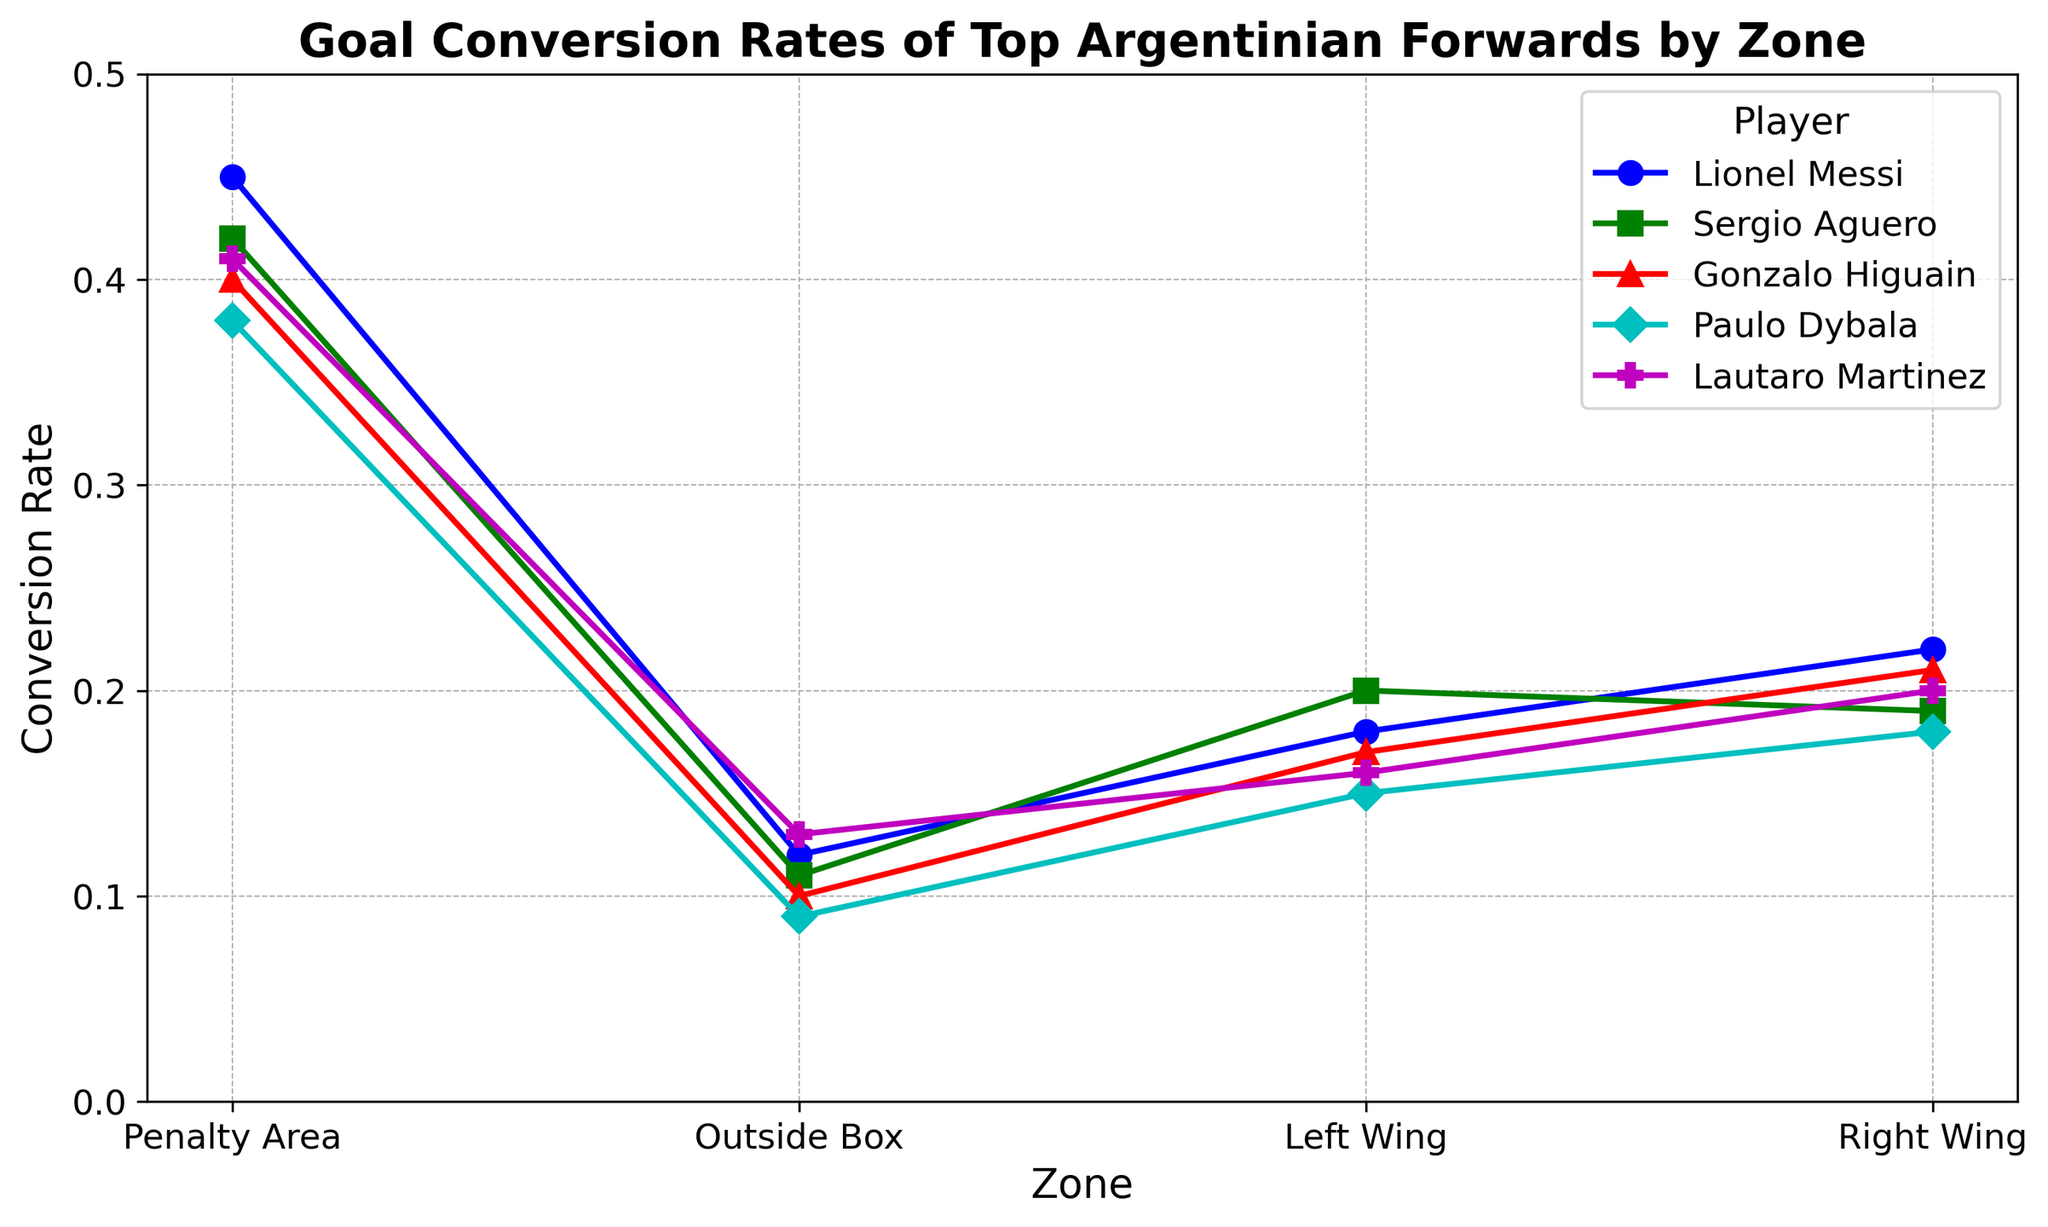Which player has the highest conversion rate in the Penalty Area? To find the player with the highest conversion rate in the Penalty Area, compare the conversion rates for each player in that zone. Lionel Messi has the highest rate at 0.45.
Answer: Lionel Messi Which zone does Paulo Dybala have the lowest conversion rate? Look at Paulo Dybala's conversion rates and find the lowest one. The lowest rate for Paulo Dybala is 0.09 in the Outside Box zone.
Answer: Outside Box Compare the conversion rates of Messi and Aguero in the Right Wing. Who has a higher rate? Compare the conversion rates of both Messi and Aguero in the Right Wing. Messi has a conversion rate of 0.22, while Aguero has 0.19. Therefore, Messi has a higher rate.
Answer: Messi Which zone shows the largest difference in conversion rate between Gonzalo Higuain and Lautaro Martinez? Calculate the differences in conversion rates for each zone. The differences are: Penalty Area (0.40 - 0.41 = -0.01), Outside Box (0.10 - 0.13 = -0.03), Left Wing (0.17 - 0.16 = 0.01), Right Wing (0.21 - 0.20 = 0.01). The largest difference is in the Outside Box (-0.03).
Answer: Outside Box What's the average conversion rate in the Left Wing for all players? Sum the conversion rates of all players in the Left Wing and divide by the number of players. The rates are Messi (0.18), Aguero (0.20), Higuain (0.17), Dybala (0.15), Martinez (0.16). The average is (0.18 + 0.20 + 0.17 + 0.15 + 0.16) / 5 = 0.172.
Answer: 0.172 In which zone does Lautaro Martinez have the highest conversion rate and what is it? Look at Lautaro Martinez's conversion rates across all zones and identify the highest one. Lautaro Martinez's highest rate is 0.41 in the Penalty Area.
Answer: Penalty Area, 0.41 How many players have a conversion rate higher than 0.40 in the Penalty Area? Check the conversion rates in the Penalty Area and count the number of players with a rate higher than 0.40. Messi (0.45), Aguero (0.42), and Martinez (0.41) all have rates higher than 0.40.
Answer: Three Who has the lowest conversion rate in the Outside Box, and what is the value? Compare the conversion rates in the Outside Box. Dybala has the lowest rate of 0.09.
Answer: Dybala, 0.09 Which player shows the most similar conversion rates between the Penalty Area and the Right Wing? Calculate the difference between the conversion rates in the Penalty Area and the Right Wing for each player. The differences are: Messi (0.45 - 0.22 = 0.23), Aguero (0.42 - 0.19 = 0.23), Higuain (0.40 - 0.21 = 0.19), Dybala (0.38 - 0.18 = 0.20), Martinez (0.41 - 0.20 = 0.21). Higuain has the smallest difference at 0.19.
Answer: Higuain 